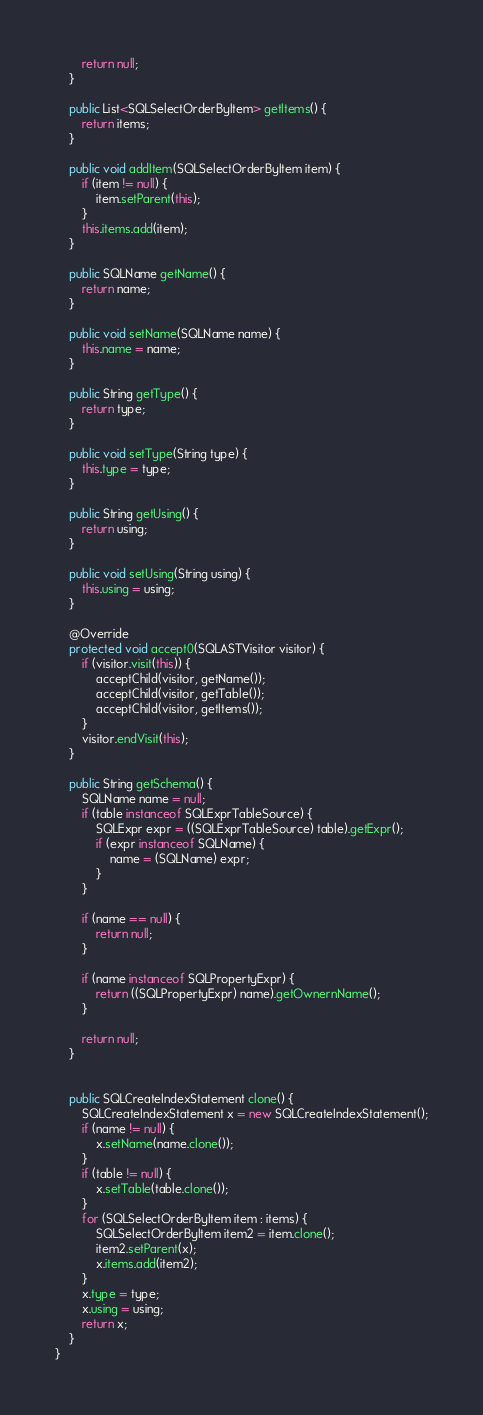<code> <loc_0><loc_0><loc_500><loc_500><_Java_>
        return null;
    }

    public List<SQLSelectOrderByItem> getItems() {
        return items;
    }

    public void addItem(SQLSelectOrderByItem item) {
        if (item != null) {
            item.setParent(this);
        }
        this.items.add(item);
    }

    public SQLName getName() {
        return name;
    }

    public void setName(SQLName name) {
        this.name = name;
    }

    public String getType() {
        return type;
    }

    public void setType(String type) {
        this.type = type;
    }
    
    public String getUsing() {
        return using;
    }

    public void setUsing(String using) {
        this.using = using;
    }

    @Override
    protected void accept0(SQLASTVisitor visitor) {
        if (visitor.visit(this)) {
            acceptChild(visitor, getName());
            acceptChild(visitor, getTable());
            acceptChild(visitor, getItems());
        }
        visitor.endVisit(this);
    }

    public String getSchema() {
        SQLName name = null;
        if (table instanceof SQLExprTableSource) {
            SQLExpr expr = ((SQLExprTableSource) table).getExpr();
            if (expr instanceof SQLName) {
                name = (SQLName) expr;
            }
        }

        if (name == null) {
            return null;
        }

        if (name instanceof SQLPropertyExpr) {
            return ((SQLPropertyExpr) name).getOwnernName();
        }

        return null;
    }


    public SQLCreateIndexStatement clone() {
        SQLCreateIndexStatement x = new SQLCreateIndexStatement();
        if (name != null) {
            x.setName(name.clone());
        }
        if (table != null) {
            x.setTable(table.clone());
        }
        for (SQLSelectOrderByItem item : items) {
            SQLSelectOrderByItem item2 = item.clone();
            item2.setParent(x);
            x.items.add(item2);
        }
        x.type = type;
        x.using = using;
        return x;
    }
}
</code> 